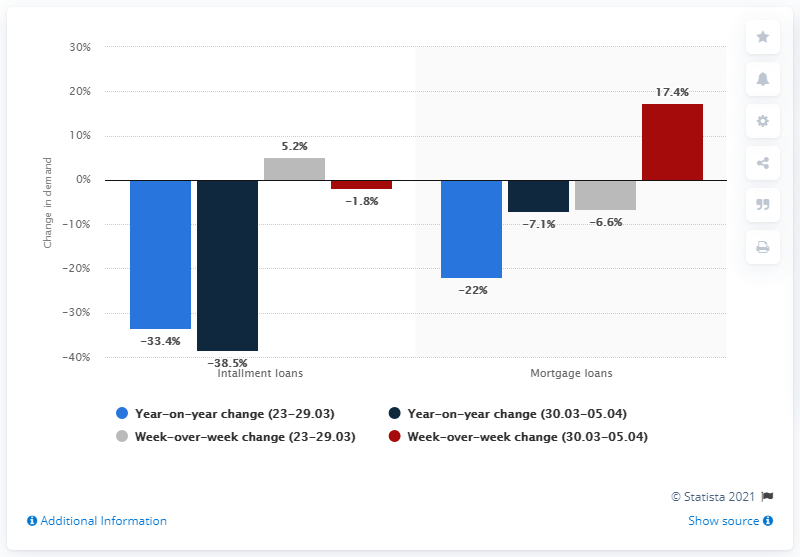List a handful of essential elements in this visual. In the week of March 30th to April 5th, there was a significant increase in the demand for housing loans, with a total demand of 17.4%. 